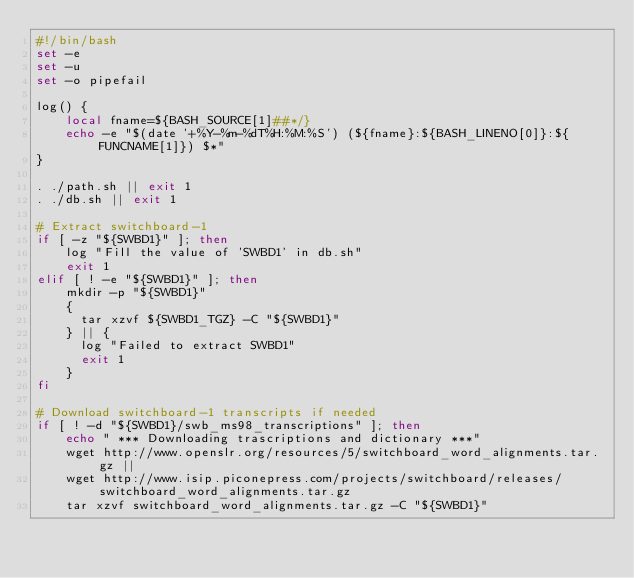Convert code to text. <code><loc_0><loc_0><loc_500><loc_500><_Bash_>#!/bin/bash
set -e
set -u
set -o pipefail

log() {
    local fname=${BASH_SOURCE[1]##*/}
    echo -e "$(date '+%Y-%m-%dT%H:%M:%S') (${fname}:${BASH_LINENO[0]}:${FUNCNAME[1]}) $*"
}

. ./path.sh || exit 1
. ./db.sh || exit 1

# Extract switchboard-1
if [ -z "${SWBD1}" ]; then
    log "Fill the value of 'SWBD1' in db.sh"
    exit 1
elif [ ! -e "${SWBD1}" ]; then
    mkdir -p "${SWBD1}"
    {
      tar xzvf ${SWBD1_TGZ} -C "${SWBD1}"
    } || {
      log "Failed to extract SWBD1"
      exit 1
    }
fi

# Download switchboard-1 transcripts if needed
if [ ! -d "${SWBD1}/swb_ms98_transcriptions" ]; then
    echo " *** Downloading trascriptions and dictionary ***"
    wget http://www.openslr.org/resources/5/switchboard_word_alignments.tar.gz ||
    wget http://www.isip.piconepress.com/projects/switchboard/releases/switchboard_word_alignments.tar.gz
    tar xzvf switchboard_word_alignments.tar.gz -C "${SWBD1}"</code> 